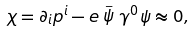<formula> <loc_0><loc_0><loc_500><loc_500>\chi = \partial _ { i } p ^ { i } - e \stackrel { \_ } { \psi } \gamma ^ { 0 } \psi \approx 0 ,</formula> 